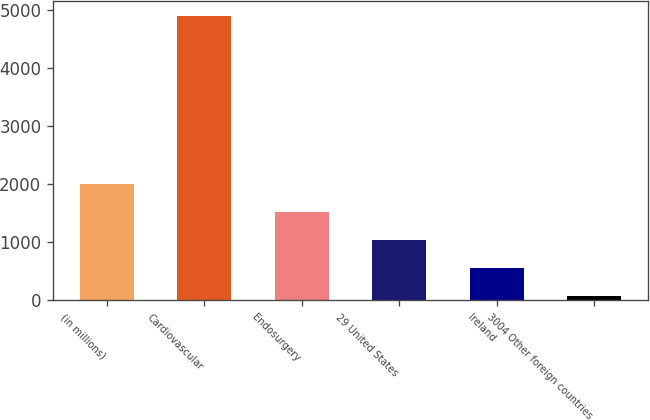Convert chart to OTSL. <chart><loc_0><loc_0><loc_500><loc_500><bar_chart><fcel>(in millions)<fcel>Cardiovascular<fcel>Endosurgery<fcel>29 United States<fcel>Ireland<fcel>3004 Other foreign countries<nl><fcel>2008.4<fcel>4907<fcel>1525.3<fcel>1042.2<fcel>559.1<fcel>76<nl></chart> 